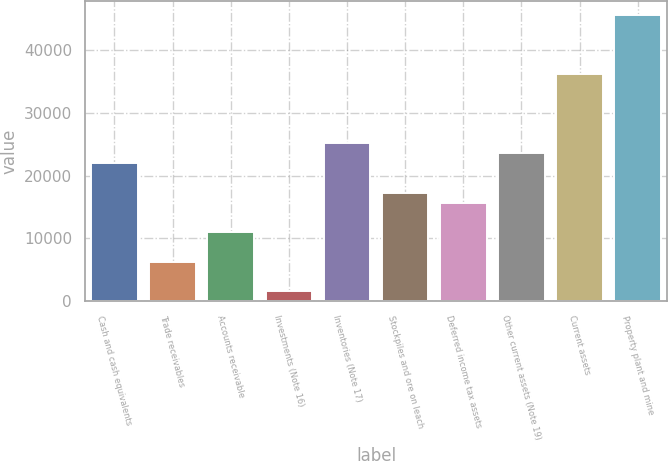<chart> <loc_0><loc_0><loc_500><loc_500><bar_chart><fcel>Cash and cash equivalents<fcel>Trade receivables<fcel>Accounts receivable<fcel>Investments (Note 16)<fcel>Inventories (Note 17)<fcel>Stockpiles and ore on leach<fcel>Deferred income tax assets<fcel>Other current assets (Note 19)<fcel>Current assets<fcel>Property plant and mine<nl><fcel>22016.2<fcel>6293.2<fcel>11010.1<fcel>1576.3<fcel>25160.8<fcel>17299.3<fcel>15727<fcel>23588.5<fcel>36166.9<fcel>45600.7<nl></chart> 